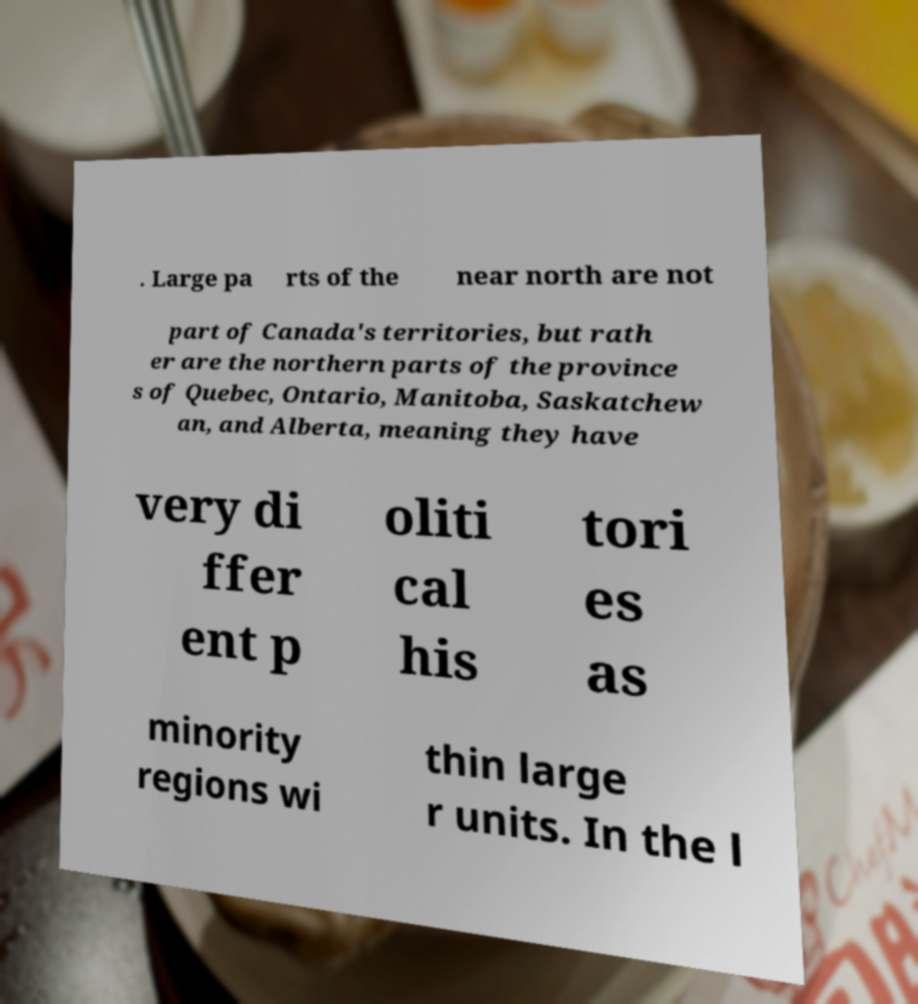Could you extract and type out the text from this image? . Large pa rts of the near north are not part of Canada's territories, but rath er are the northern parts of the province s of Quebec, Ontario, Manitoba, Saskatchew an, and Alberta, meaning they have very di ffer ent p oliti cal his tori es as minority regions wi thin large r units. In the l 